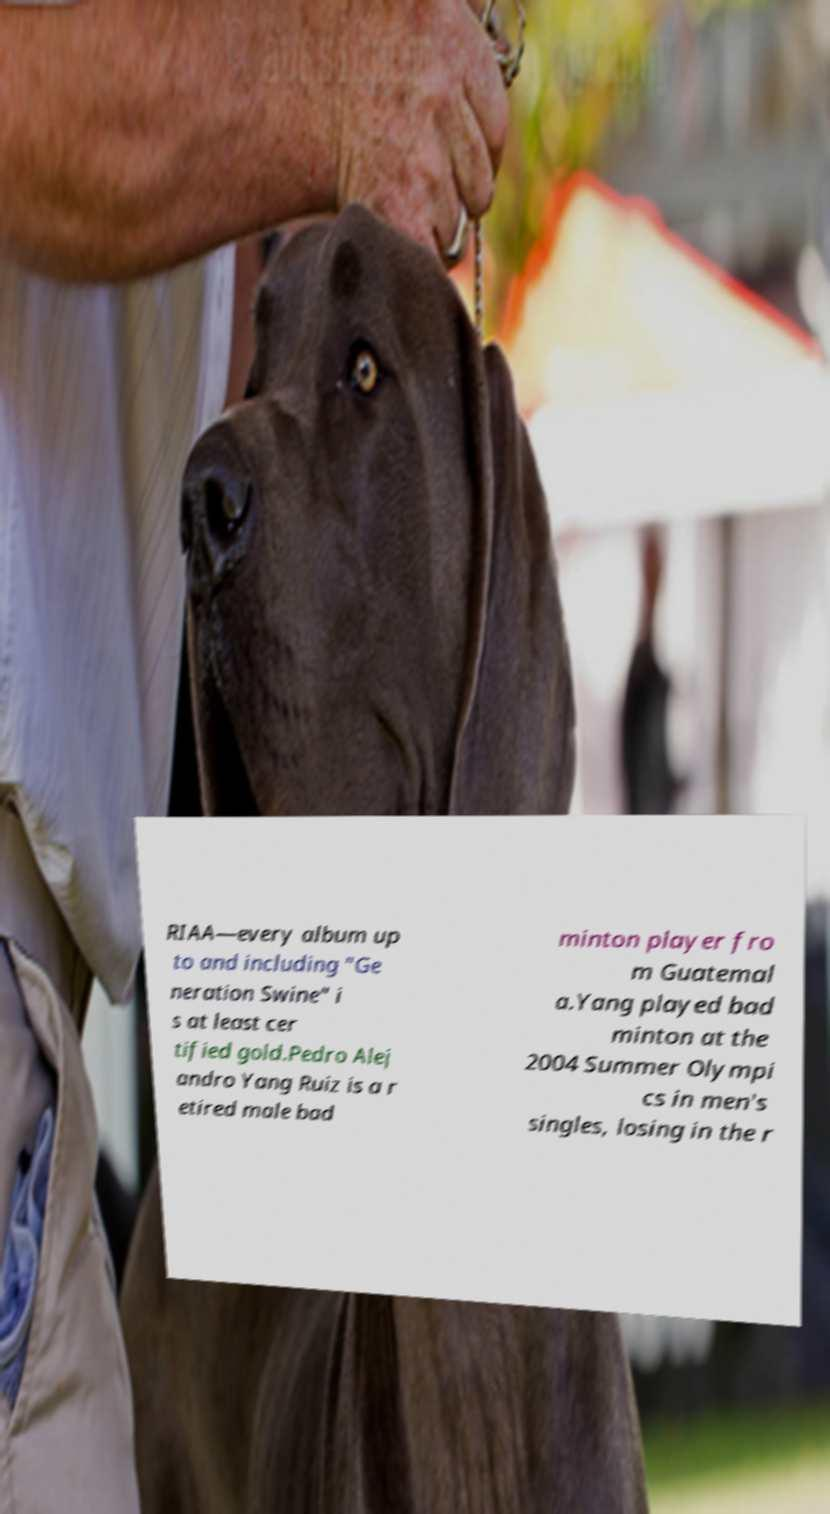I need the written content from this picture converted into text. Can you do that? RIAA―every album up to and including "Ge neration Swine" i s at least cer tified gold.Pedro Alej andro Yang Ruiz is a r etired male bad minton player fro m Guatemal a.Yang played bad minton at the 2004 Summer Olympi cs in men's singles, losing in the r 